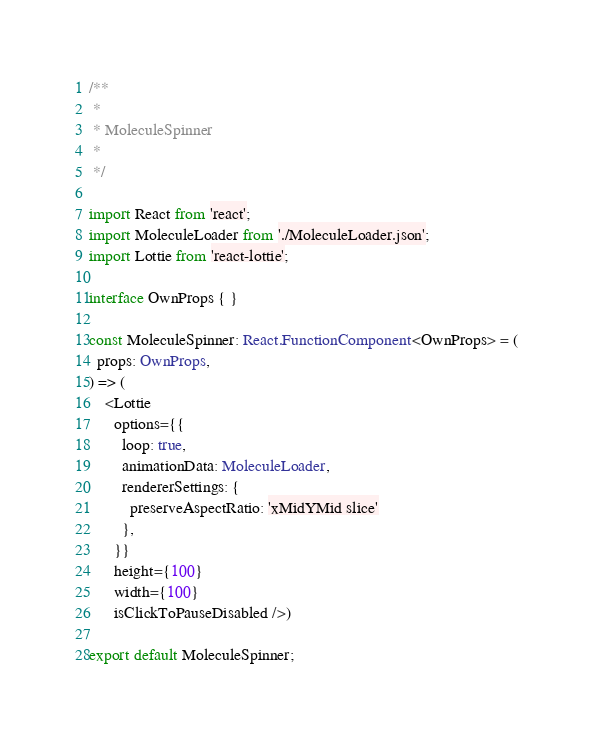Convert code to text. <code><loc_0><loc_0><loc_500><loc_500><_TypeScript_>/**
 *
 * MoleculeSpinner
 *
 */

import React from 'react';
import MoleculeLoader from './MoleculeLoader.json';
import Lottie from 'react-lottie';

interface OwnProps { }

const MoleculeSpinner: React.FunctionComponent<OwnProps> = (
  props: OwnProps,
) => (
    <Lottie
      options={{
        loop: true,
        animationData: MoleculeLoader,
        rendererSettings: {
          preserveAspectRatio: 'xMidYMid slice'
        },
      }}
      height={100}
      width={100}
      isClickToPauseDisabled />)

export default MoleculeSpinner;
</code> 